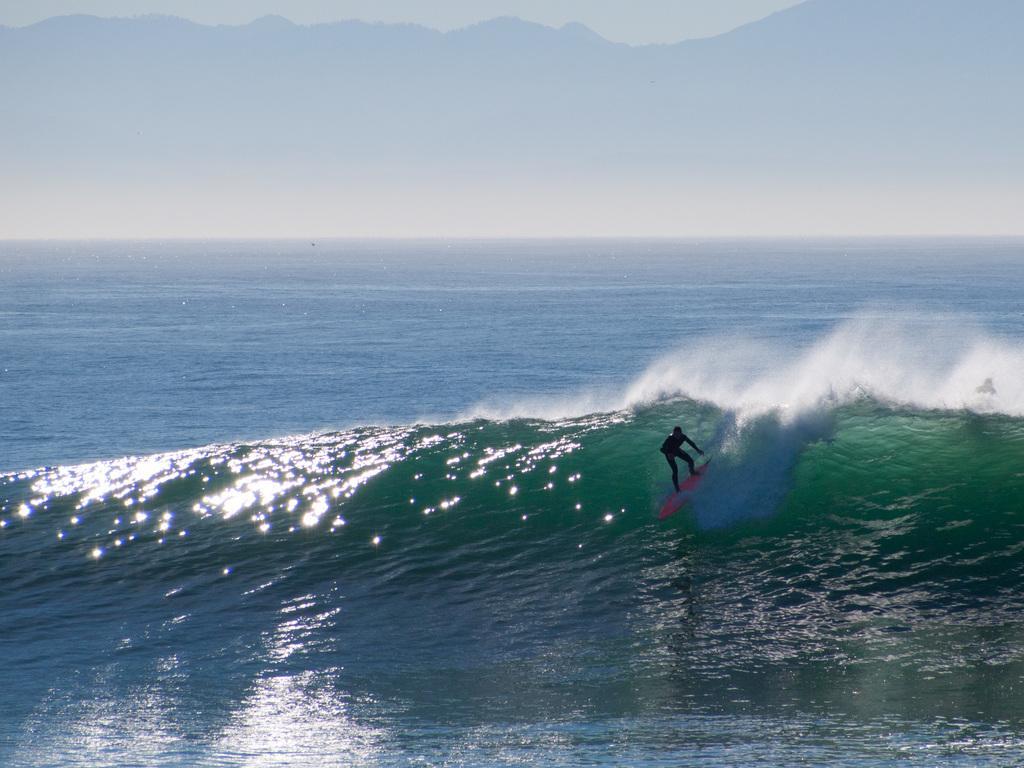In one or two sentences, can you explain what this image depicts? In the image there is a person surfing in the ocean and above its sky with clouds. 